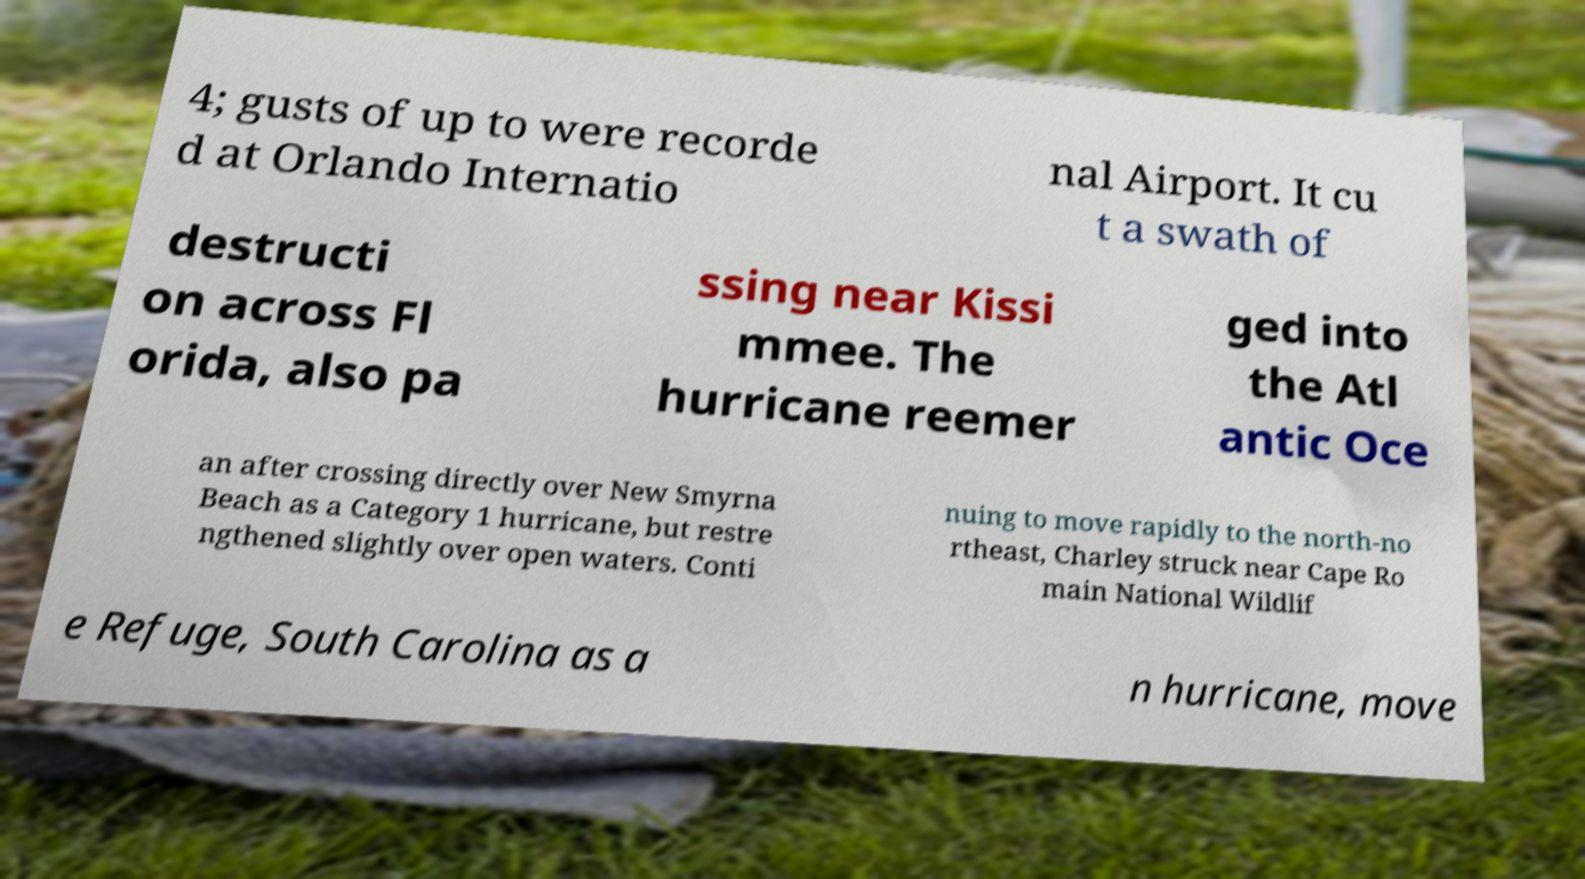Please identify and transcribe the text found in this image. 4; gusts of up to were recorde d at Orlando Internatio nal Airport. It cu t a swath of destructi on across Fl orida, also pa ssing near Kissi mmee. The hurricane reemer ged into the Atl antic Oce an after crossing directly over New Smyrna Beach as a Category 1 hurricane, but restre ngthened slightly over open waters. Conti nuing to move rapidly to the north-no rtheast, Charley struck near Cape Ro main National Wildlif e Refuge, South Carolina as a n hurricane, move 